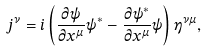Convert formula to latex. <formula><loc_0><loc_0><loc_500><loc_500>j ^ { \nu } = i \left ( { \frac { \partial \psi } { \partial x ^ { \mu } } } \psi ^ { * } - { \frac { \partial \psi ^ { * } } { \partial x ^ { \mu } } } \psi \right ) \eta ^ { \nu \mu } ,</formula> 